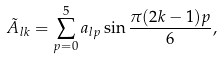<formula> <loc_0><loc_0><loc_500><loc_500>\tilde { A } _ { l k } = \sum _ { p = 0 } ^ { 5 } a _ { l p } \sin \frac { \pi ( 2 k - 1 ) p } { 6 } ,</formula> 